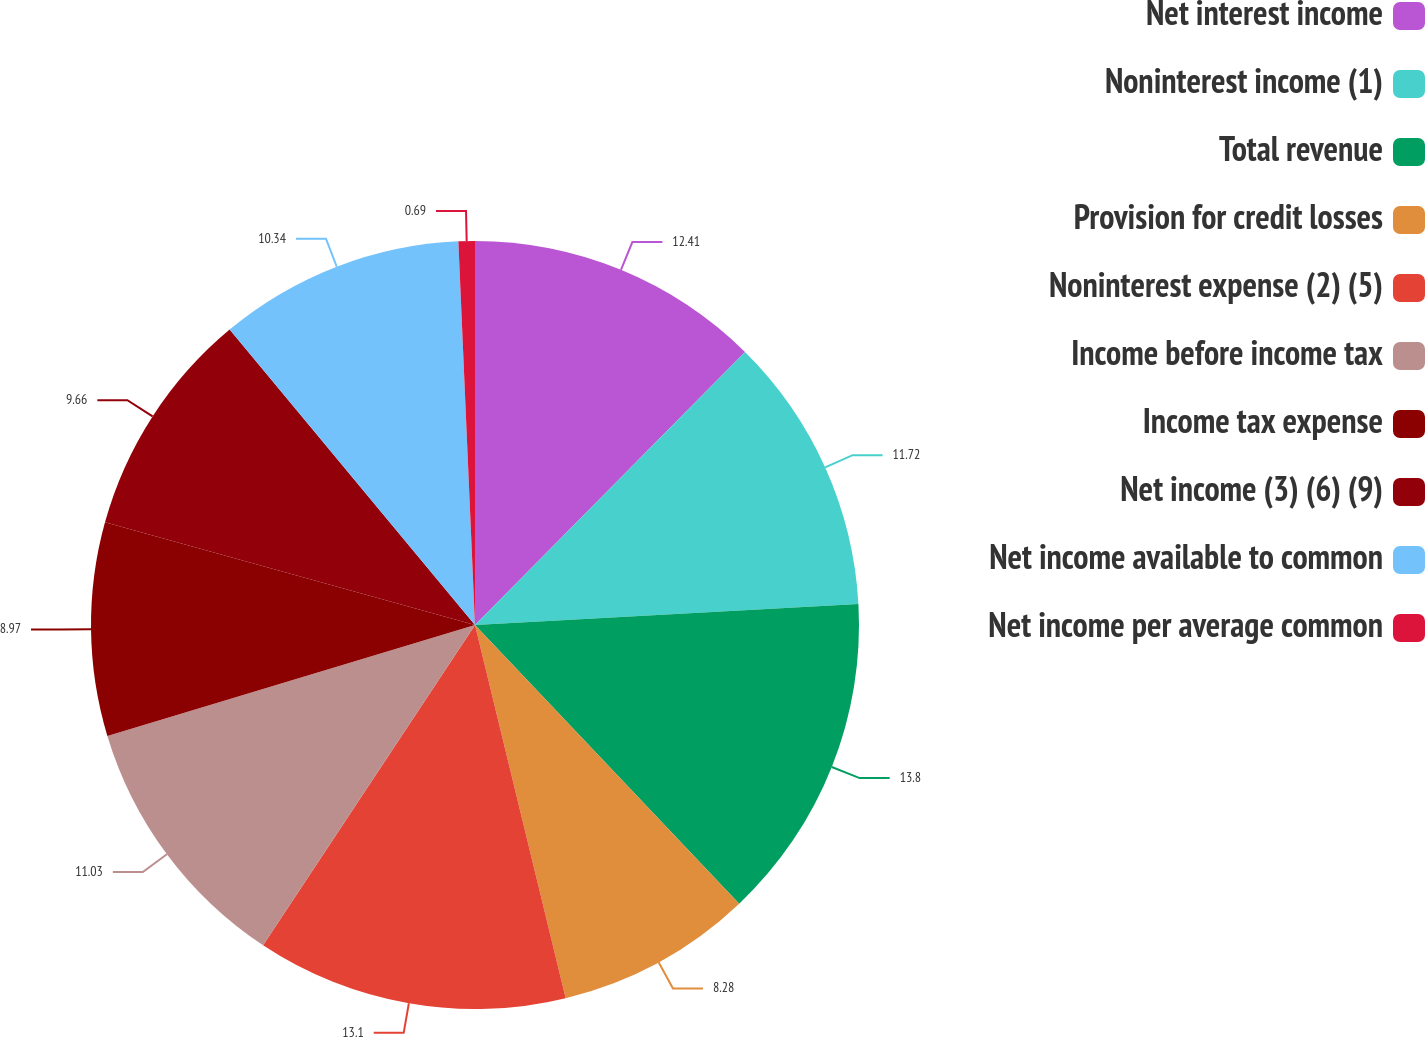Convert chart to OTSL. <chart><loc_0><loc_0><loc_500><loc_500><pie_chart><fcel>Net interest income<fcel>Noninterest income (1)<fcel>Total revenue<fcel>Provision for credit losses<fcel>Noninterest expense (2) (5)<fcel>Income before income tax<fcel>Income tax expense<fcel>Net income (3) (6) (9)<fcel>Net income available to common<fcel>Net income per average common<nl><fcel>12.41%<fcel>11.72%<fcel>13.79%<fcel>8.28%<fcel>13.1%<fcel>11.03%<fcel>8.97%<fcel>9.66%<fcel>10.34%<fcel>0.69%<nl></chart> 